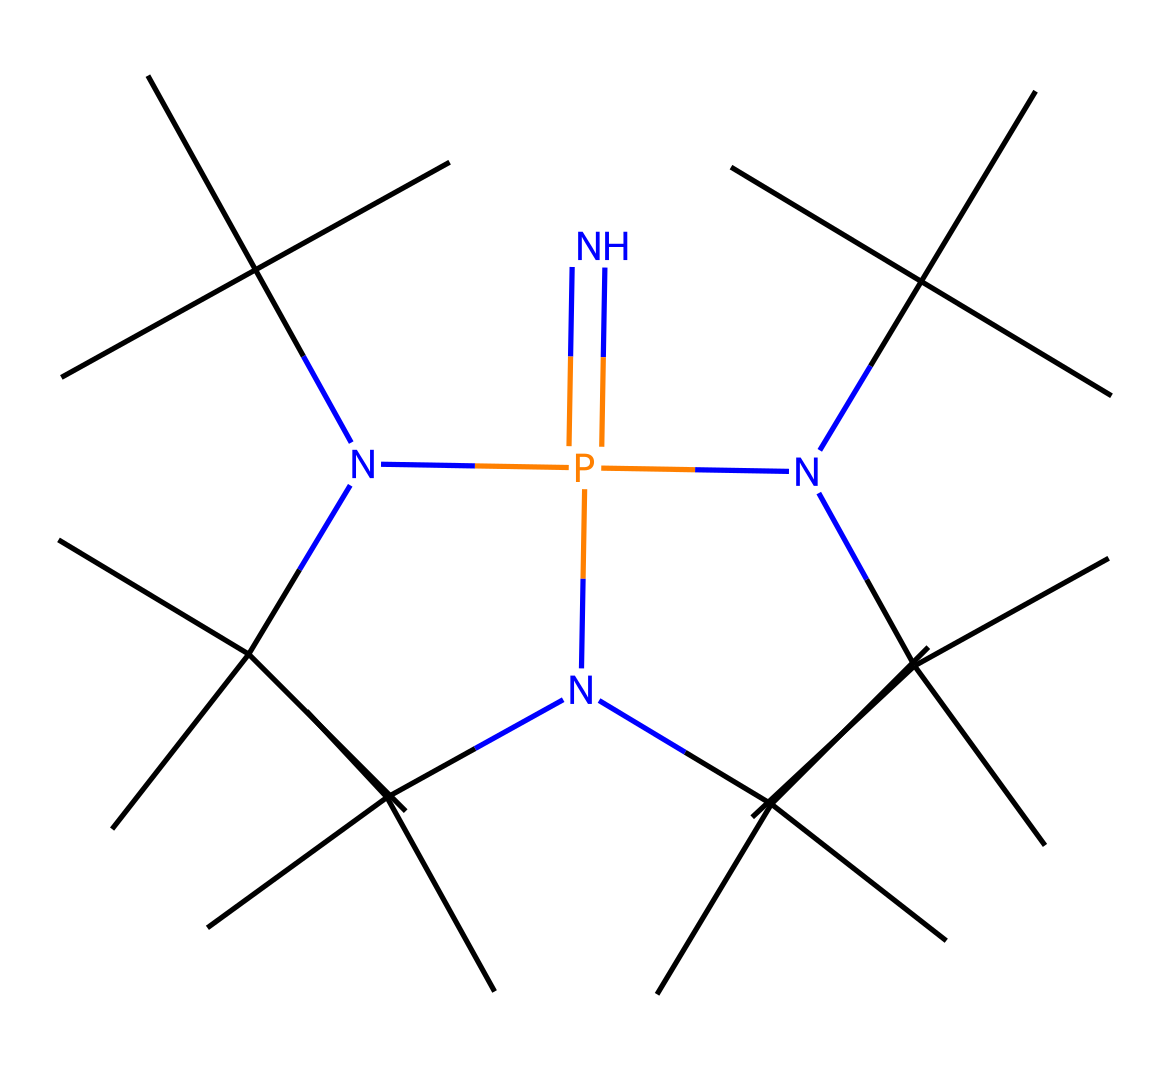What is the primary functional group in this molecule? The molecule contains a phosphazene structure characterized by the presence of nitrogen and phosphorus atoms. The central nitrogen atom forms part of the phosphazene ring, indicating that the primary functional group is that of a phosphazene.
Answer: phosphazene How many tertiary butyl groups are present? Through examination of the SMILES representation, each side of the central nitrogen atom has three attached groups. Each of these groups is a tert-butyl group, revealing that there are nine tertiary butyl groups in total.
Answer: nine What type of base is represented by this chemical structure? The inclusion of multiple nitrogen atoms along with a phosphorous atom suggests that this molecule is classified as a superbase. Superbases are notable for their strong basicity, and this structure exemplifies that property due to its configuration.
Answer: superbase How many phosphorus atoms are in the chemical structure? Counting the atoms in the SMILES representation indicates that there is one phosphorus atom in the molecular structure. A careful look at the substance demonstrates that this is a single phosphorus entity bonded with nitrogen atoms.
Answer: one What type of sustainability practices can this superbase facilitate? The properties of this superbase allow it to be used in various sustainable chemistry practices, including polymer synthesis and catalysis. Its ability to deprotonate compounds effectively makes it a critical component in green chemistry settings.
Answer: polymer synthesis and catalysis 